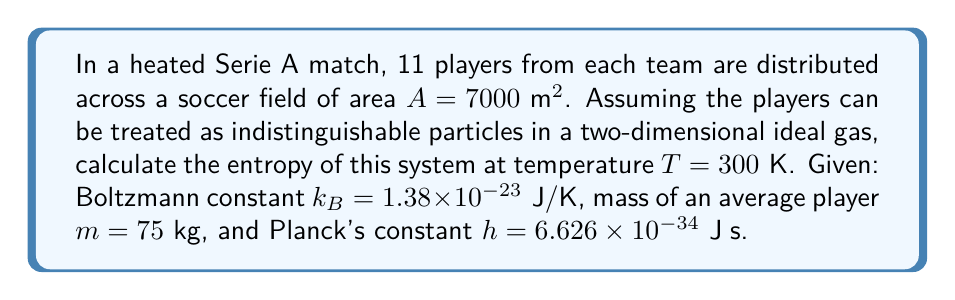Can you answer this question? To calculate the entropy of this system, we'll use the Sackur-Tetrode equation adapted for a 2D ideal gas:

1) The entropy $S$ for a 2D ideal gas is given by:

   $$S = Nk_B \left[\ln\left(\frac{A}{N}\left(\frac{2\pi mk_BT}{h^2}\right)\right) + 2\right]$$

2) We have $N = 22$ players total, $A = 7000 \text{ m}^2$, $T = 300 \text{ K}$, $m = 75 \text{ kg}$, $k_B = 1.38 \times 10^{-23} \text{ J/K}$, and $h = 6.626 \times 10^{-34} \text{ J⋅s}$

3) Let's calculate the term inside the logarithm first:

   $$\frac{A}{N} = \frac{7000}{22} = 318.18 \text{ m}^2$$

   $$\frac{2\pi mk_BT}{h^2} = \frac{2\pi \cdot 75 \cdot 1.38 \times 10^{-23} \cdot 300}{(6.626 \times 10^{-34})^2} = 1.47 \times 10^{44} \text{ m}^{-2}$$

4) Now, let's multiply these terms:

   $$\frac{A}{N}\left(\frac{2\pi mk_BT}{h^2}\right) = 318.18 \cdot 1.47 \times 10^{44} = 4.68 \times 10^{46}$$

5) Taking the natural logarithm:

   $$\ln\left(\frac{A}{N}\left(\frac{2\pi mk_BT}{h^2}\right)\right) = \ln(4.68 \times 10^{46}) = 107.57$$

6) Now we can plug everything into the entropy equation:

   $$S = 22 \cdot 1.38 \times 10^{-23} \cdot (107.57 + 2) = 3.32 \times 10^{-21} \text{ J/K}$$

Thus, the entropy of the system is approximately $3.32 \times 10^{-21} \text{ J/K}$.
Answer: $3.32 \times 10^{-21} \text{ J/K}$ 